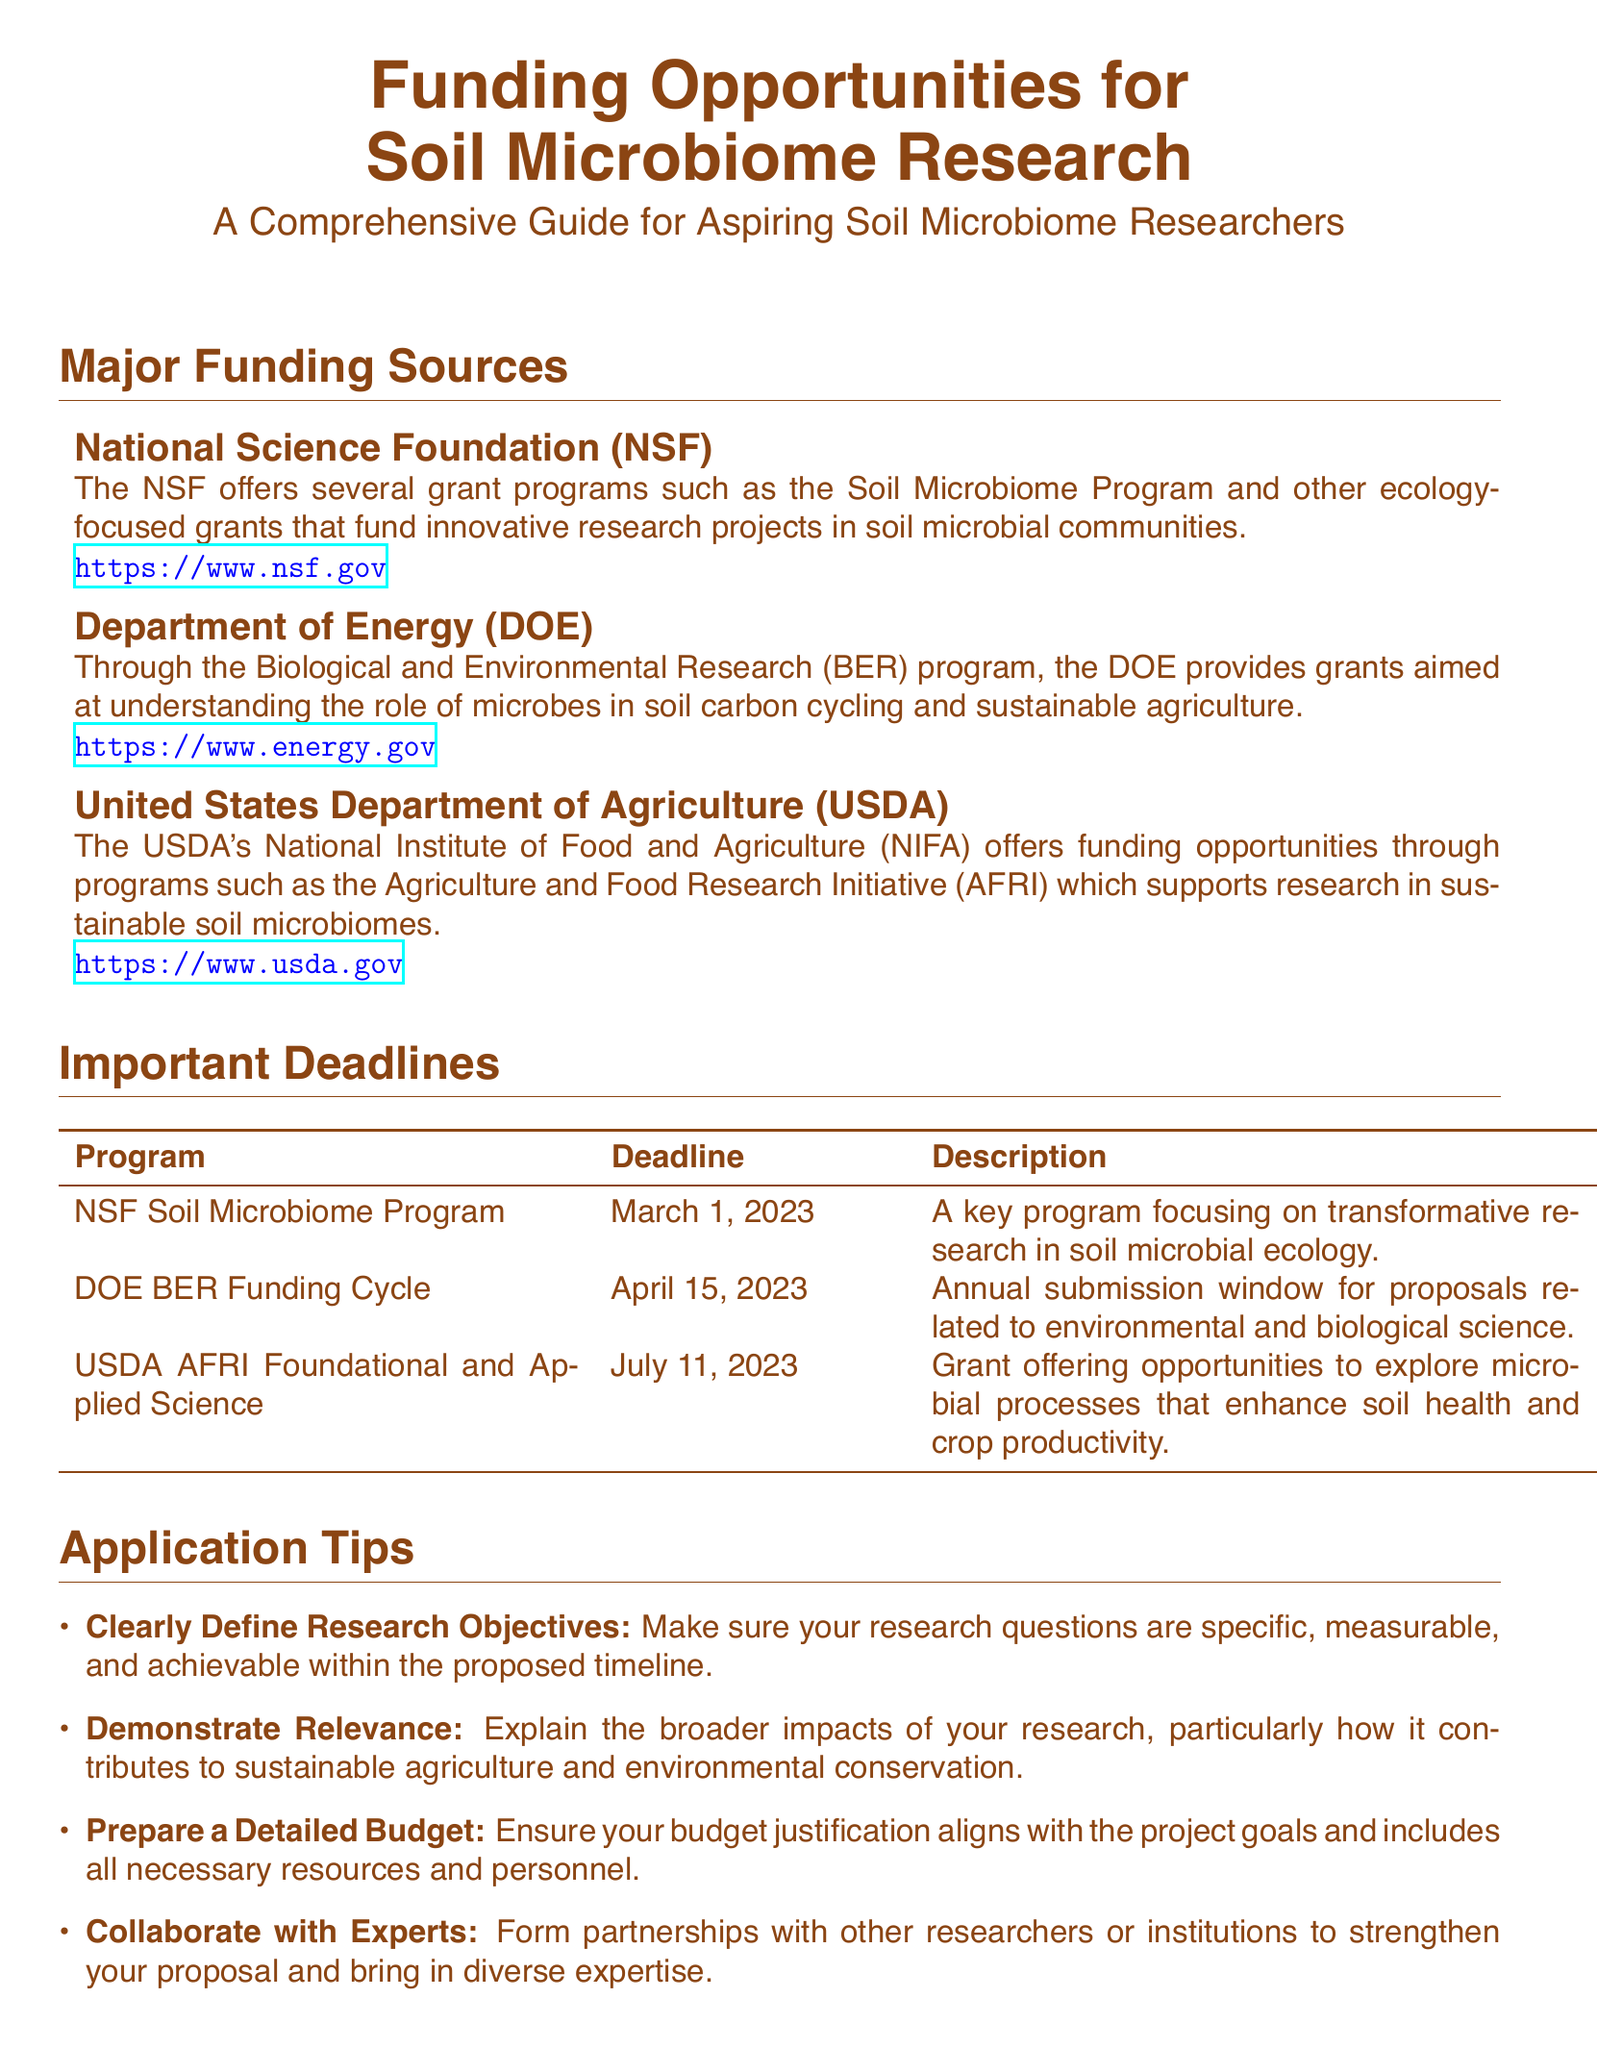What is the title of the document? The title of the document is prominently displayed at the top and states its focus on funding opportunities for soil microbiome research.
Answer: Funding Opportunities for Soil Microbiome Research What is the first funding source listed? The first funding source is mentioned in the section for major funding sources, specifically identifying the agency that offers grants.
Answer: National Science Foundation (NSF) What is the deadline for the USDA AFRI Foundational and Applied Science program? The deadline for USDA AFRI is specified in the table of important deadlines, clearly stating when proposals must be submitted.
Answer: July 11, 2023 What is one application tip provided in the document? The document includes a list of application tips, each focusing on different aspects of preparing funding proposals.
Answer: Clearly Define Research Objectives How many major funding sources are mentioned? By counting the listed items in the major funding sources section, we can determine the total number of sources highlighted.
Answer: Three What is the email address for the Department of Energy BER? The document contains a table with contact information for various agencies, including their email addresses.
Answer: berprograms@science.doe.gov Is collaboration encouraged in the application tips? The application tips section emphasizes the importance of forming partnerships and bringing diverse expertise into proposals.
Answer: Yes What is the primary focus of the DOE's funding? The document outlines the specific research area that the Department of Energy supports through grants in soil microbial research.
Answer: Microbes in soil carbon cycling and sustainable agriculture What type of document is this? The overall structure and content of the document reflect its purpose and target audience.
Answer: Playbill 